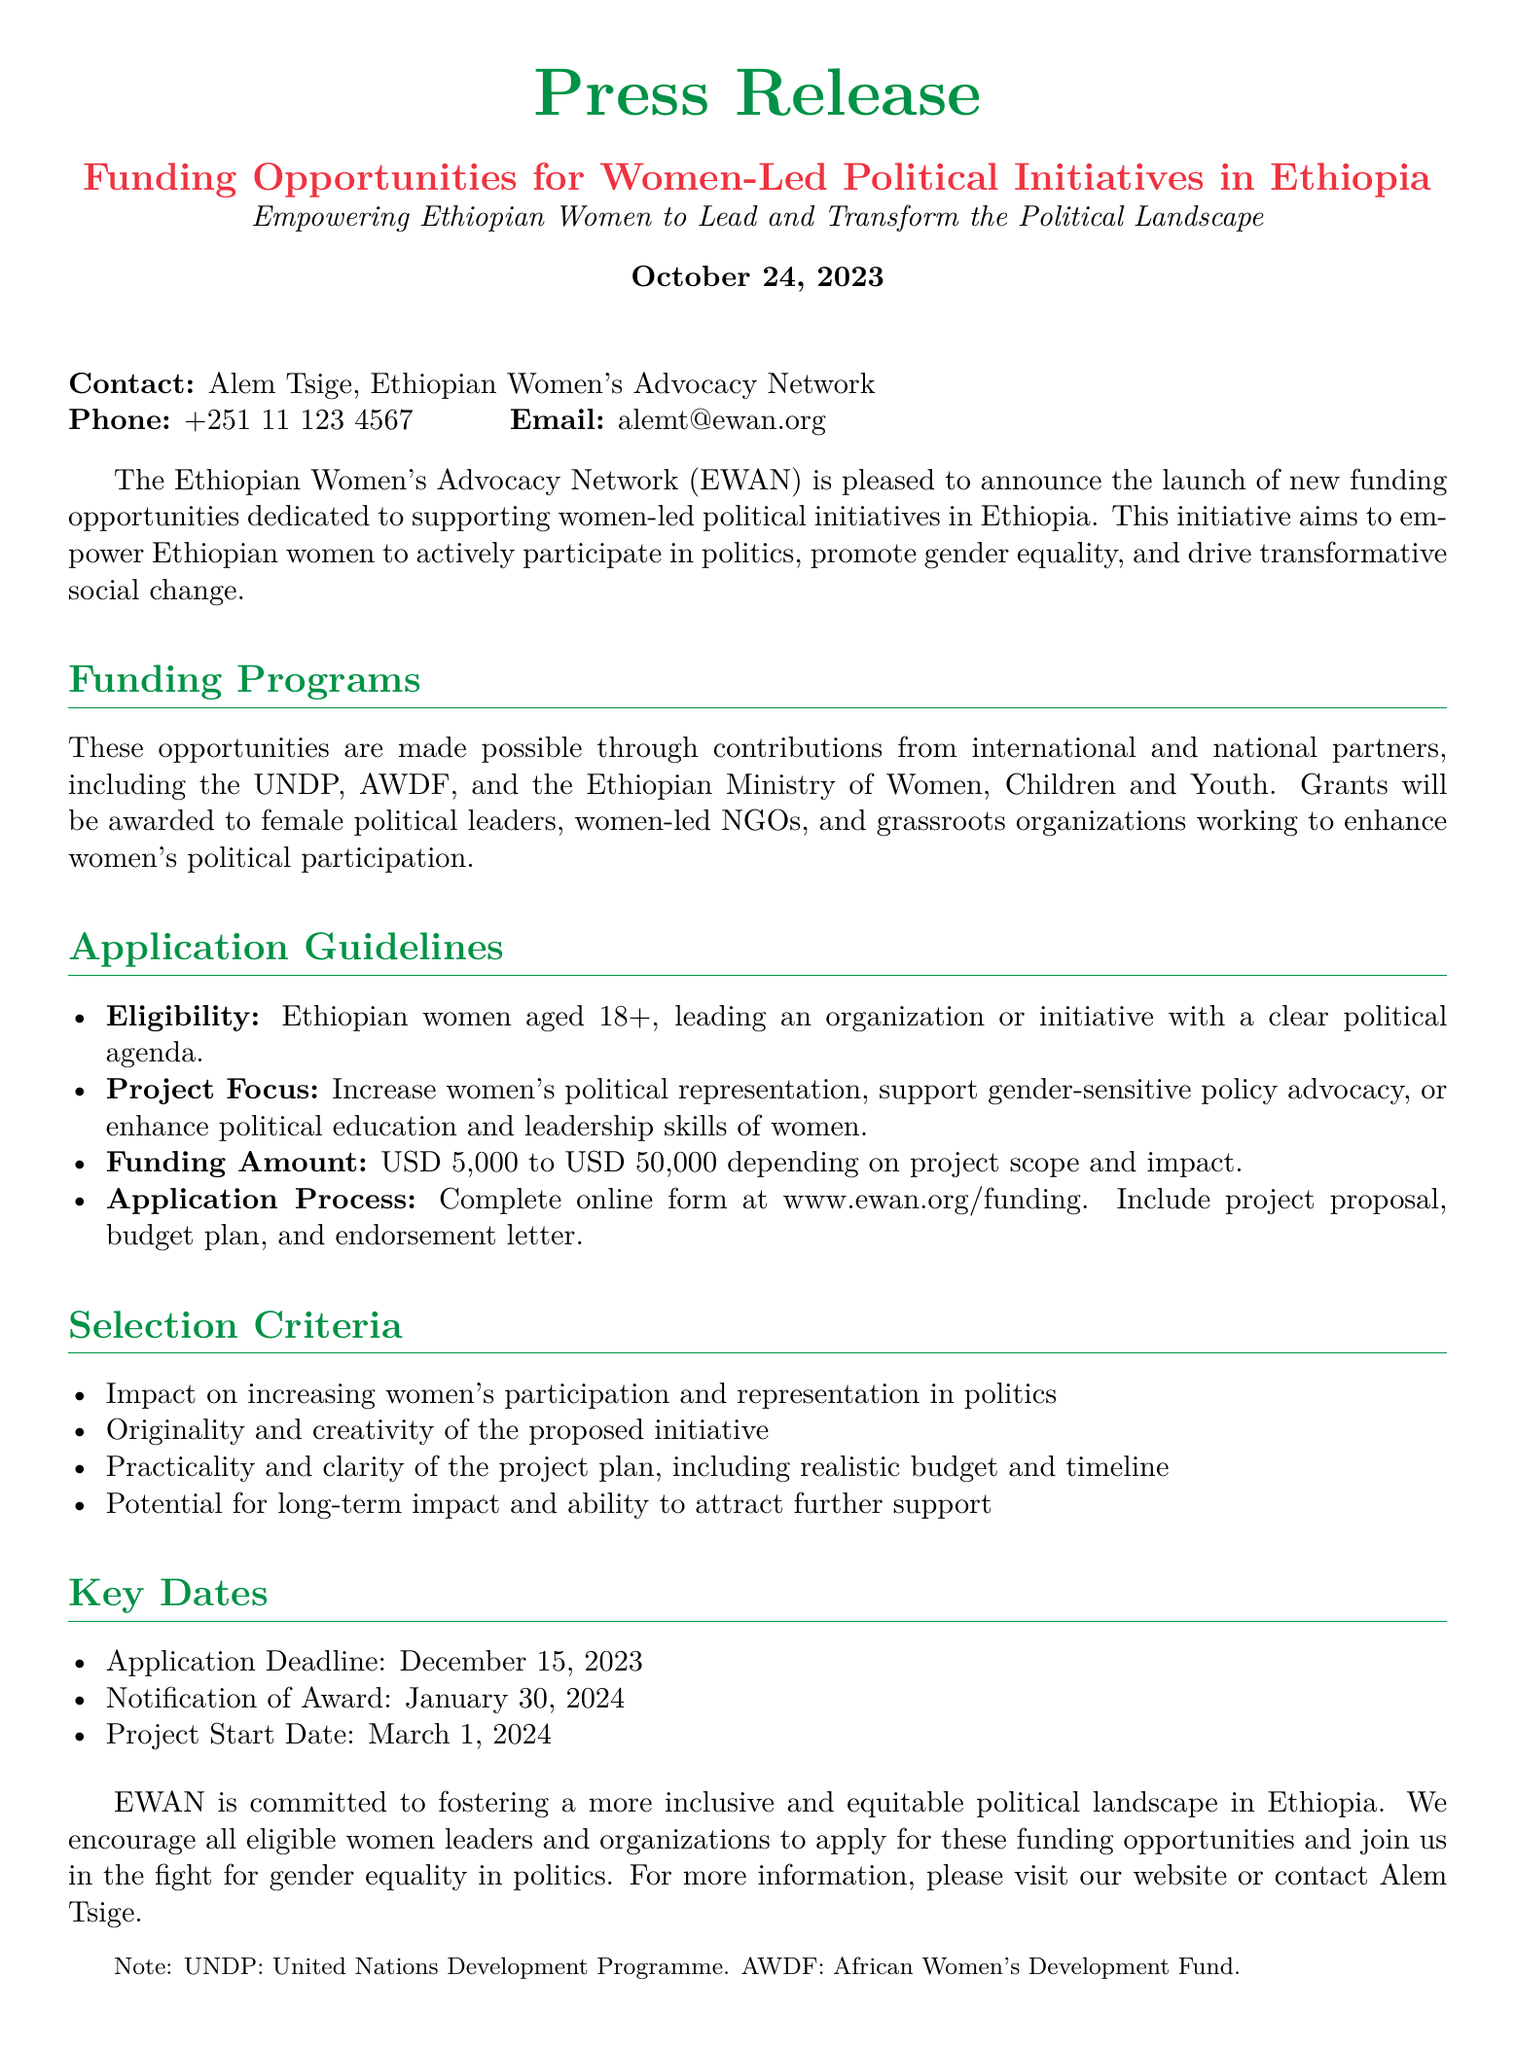what is the organization launching the funding opportunities? The document states that the Ethiopian Women's Advocacy Network (EWAN) is launching the funding opportunities.
Answer: Ethiopian Women's Advocacy Network (EWAN) what is the funding range available for projects? The funding amount specified in the document ranges from USD 5,000 to USD 50,000 depending on project scope and impact.
Answer: USD 5,000 to USD 50,000 what is the application deadline? The document provides December 15, 2023 as the application deadline for funding opportunities.
Answer: December 15, 2023 who is eligible to apply for the funding? Eligibility criteria state that applicants must be Ethiopian women aged 18+, leading an organization or initiative with a clear political agenda.
Answer: Ethiopian women aged 18+ what are the selection criteria based on? The selection criteria include the impact on increasing women's participation, originality of the initiative, practicality of the plan, and long-term impact potential.
Answer: Impact, originality, practicality, long-term impact what is the notification date for award recipients? According to the document, award recipients will be notified on January 30, 2024.
Answer: January 30, 2024 what is the primary goal of the funding initiative? The primary aim of this initiative is to empower Ethiopian women to actively participate in politics and promote gender equality.
Answer: Empowering Ethiopian women in politics and promoting gender equality what types of organizations can apply for the funding? The document specifies that grants will be awarded to female political leaders, women-led NGOs, and grassroots organizations.
Answer: Female political leaders, women-led NGOs, grassroots organizations what should be included in the application submission? The application submission should include a project proposal, budget plan, and endorsement letter.
Answer: Project proposal, budget plan, endorsement letter 